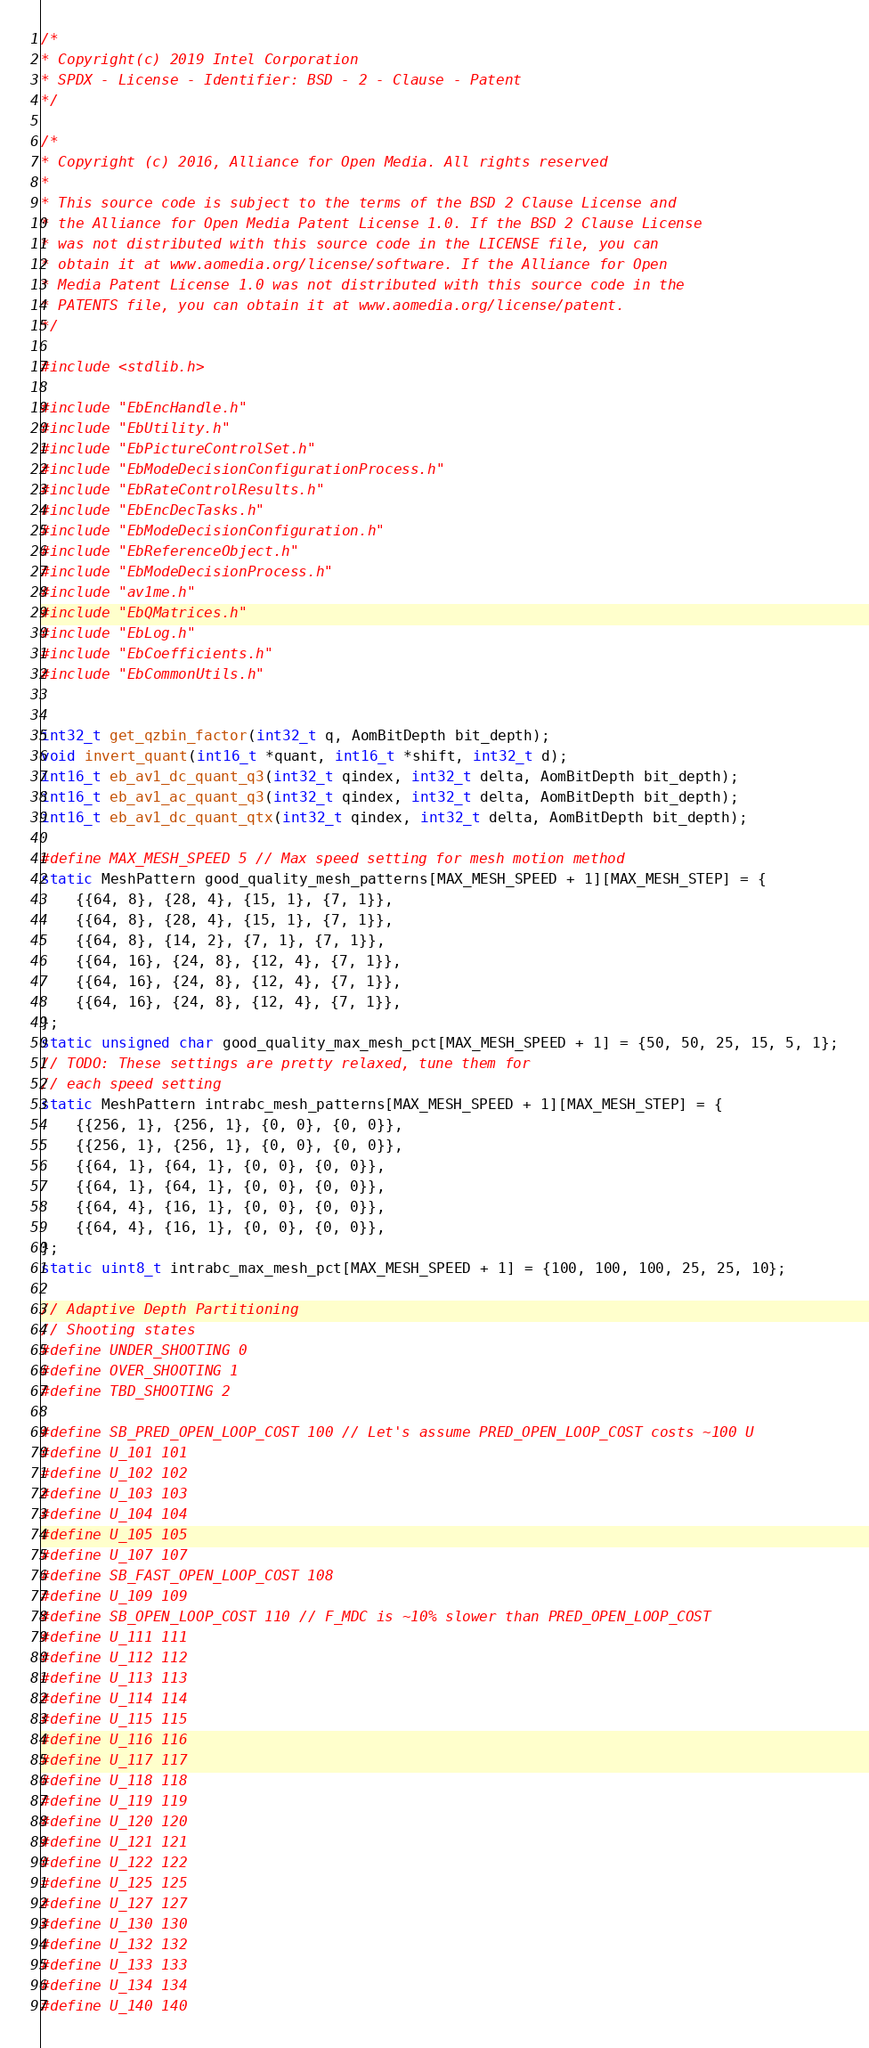Convert code to text. <code><loc_0><loc_0><loc_500><loc_500><_C_>/*
* Copyright(c) 2019 Intel Corporation
* SPDX - License - Identifier: BSD - 2 - Clause - Patent
*/

/*
* Copyright (c) 2016, Alliance for Open Media. All rights reserved
*
* This source code is subject to the terms of the BSD 2 Clause License and
* the Alliance for Open Media Patent License 1.0. If the BSD 2 Clause License
* was not distributed with this source code in the LICENSE file, you can
* obtain it at www.aomedia.org/license/software. If the Alliance for Open
* Media Patent License 1.0 was not distributed with this source code in the
* PATENTS file, you can obtain it at www.aomedia.org/license/patent.
*/

#include <stdlib.h>

#include "EbEncHandle.h"
#include "EbUtility.h"
#include "EbPictureControlSet.h"
#include "EbModeDecisionConfigurationProcess.h"
#include "EbRateControlResults.h"
#include "EbEncDecTasks.h"
#include "EbModeDecisionConfiguration.h"
#include "EbReferenceObject.h"
#include "EbModeDecisionProcess.h"
#include "av1me.h"
#include "EbQMatrices.h"
#include "EbLog.h"
#include "EbCoefficients.h"
#include "EbCommonUtils.h"


int32_t get_qzbin_factor(int32_t q, AomBitDepth bit_depth);
void invert_quant(int16_t *quant, int16_t *shift, int32_t d);
int16_t eb_av1_dc_quant_q3(int32_t qindex, int32_t delta, AomBitDepth bit_depth);
int16_t eb_av1_ac_quant_q3(int32_t qindex, int32_t delta, AomBitDepth bit_depth);
int16_t eb_av1_dc_quant_qtx(int32_t qindex, int32_t delta, AomBitDepth bit_depth);

#define MAX_MESH_SPEED 5 // Max speed setting for mesh motion method
static MeshPattern good_quality_mesh_patterns[MAX_MESH_SPEED + 1][MAX_MESH_STEP] = {
    {{64, 8}, {28, 4}, {15, 1}, {7, 1}},
    {{64, 8}, {28, 4}, {15, 1}, {7, 1}},
    {{64, 8}, {14, 2}, {7, 1}, {7, 1}},
    {{64, 16}, {24, 8}, {12, 4}, {7, 1}},
    {{64, 16}, {24, 8}, {12, 4}, {7, 1}},
    {{64, 16}, {24, 8}, {12, 4}, {7, 1}},
};
static unsigned char good_quality_max_mesh_pct[MAX_MESH_SPEED + 1] = {50, 50, 25, 15, 5, 1};
// TODO: These settings are pretty relaxed, tune them for
// each speed setting
static MeshPattern intrabc_mesh_patterns[MAX_MESH_SPEED + 1][MAX_MESH_STEP] = {
    {{256, 1}, {256, 1}, {0, 0}, {0, 0}},
    {{256, 1}, {256, 1}, {0, 0}, {0, 0}},
    {{64, 1}, {64, 1}, {0, 0}, {0, 0}},
    {{64, 1}, {64, 1}, {0, 0}, {0, 0}},
    {{64, 4}, {16, 1}, {0, 0}, {0, 0}},
    {{64, 4}, {16, 1}, {0, 0}, {0, 0}},
};
static uint8_t intrabc_max_mesh_pct[MAX_MESH_SPEED + 1] = {100, 100, 100, 25, 25, 10};

// Adaptive Depth Partitioning
// Shooting states
#define UNDER_SHOOTING 0
#define OVER_SHOOTING 1
#define TBD_SHOOTING 2

#define SB_PRED_OPEN_LOOP_COST 100 // Let's assume PRED_OPEN_LOOP_COST costs ~100 U
#define U_101 101
#define U_102 102
#define U_103 103
#define U_104 104
#define U_105 105
#define U_107 107
#define SB_FAST_OPEN_LOOP_COST 108
#define U_109 109
#define SB_OPEN_LOOP_COST 110 // F_MDC is ~10% slower than PRED_OPEN_LOOP_COST
#define U_111 111
#define U_112 112
#define U_113 113
#define U_114 114
#define U_115 115
#define U_116 116
#define U_117 117
#define U_118 118
#define U_119 119
#define U_120 120
#define U_121 121
#define U_122 122
#define U_125 125
#define U_127 127
#define U_130 130
#define U_132 132
#define U_133 133
#define U_134 134
#define U_140 140</code> 